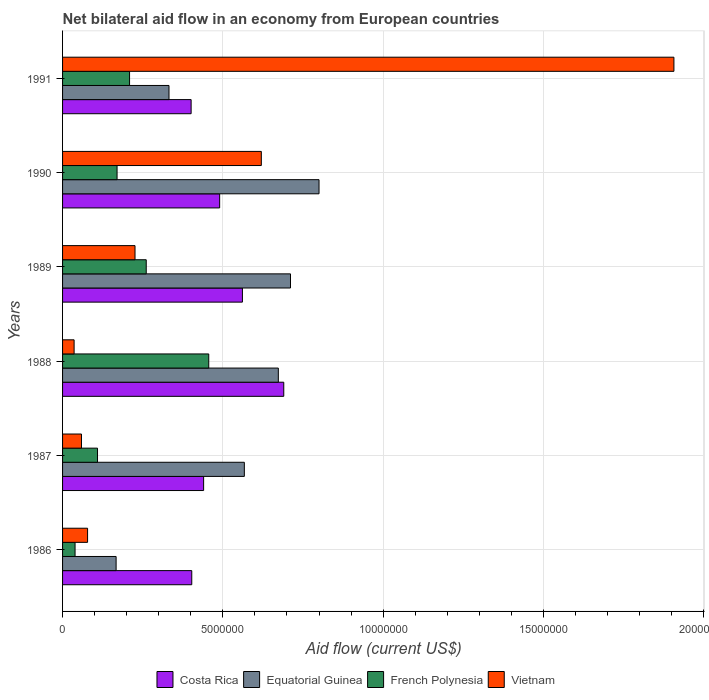How many different coloured bars are there?
Offer a terse response. 4. How many groups of bars are there?
Your answer should be compact. 6. Are the number of bars on each tick of the Y-axis equal?
Give a very brief answer. Yes. How many bars are there on the 3rd tick from the top?
Provide a succinct answer. 4. How many bars are there on the 6th tick from the bottom?
Your response must be concise. 4. What is the net bilateral aid flow in Vietnam in 1986?
Ensure brevity in your answer.  7.80e+05. In which year was the net bilateral aid flow in French Polynesia maximum?
Give a very brief answer. 1988. What is the total net bilateral aid flow in French Polynesia in the graph?
Your answer should be compact. 1.24e+07. What is the difference between the net bilateral aid flow in Costa Rica in 1988 and the net bilateral aid flow in French Polynesia in 1989?
Your response must be concise. 4.29e+06. What is the average net bilateral aid flow in Costa Rica per year?
Your response must be concise. 4.98e+06. In how many years, is the net bilateral aid flow in Costa Rica greater than 7000000 US$?
Provide a succinct answer. 0. What is the ratio of the net bilateral aid flow in French Polynesia in 1989 to that in 1991?
Offer a very short reply. 1.25. Is the net bilateral aid flow in Vietnam in 1987 less than that in 1991?
Your answer should be very brief. Yes. Is the difference between the net bilateral aid flow in Equatorial Guinea in 1989 and 1990 greater than the difference between the net bilateral aid flow in Costa Rica in 1989 and 1990?
Ensure brevity in your answer.  No. What is the difference between the highest and the second highest net bilateral aid flow in Costa Rica?
Offer a terse response. 1.29e+06. What is the difference between the highest and the lowest net bilateral aid flow in Equatorial Guinea?
Provide a short and direct response. 6.33e+06. Is the sum of the net bilateral aid flow in Vietnam in 1990 and 1991 greater than the maximum net bilateral aid flow in Equatorial Guinea across all years?
Make the answer very short. Yes. Is it the case that in every year, the sum of the net bilateral aid flow in Costa Rica and net bilateral aid flow in French Polynesia is greater than the sum of net bilateral aid flow in Vietnam and net bilateral aid flow in Equatorial Guinea?
Your response must be concise. No. What does the 3rd bar from the top in 1989 represents?
Provide a succinct answer. Equatorial Guinea. What does the 2nd bar from the bottom in 1986 represents?
Your answer should be very brief. Equatorial Guinea. Is it the case that in every year, the sum of the net bilateral aid flow in Equatorial Guinea and net bilateral aid flow in Costa Rica is greater than the net bilateral aid flow in Vietnam?
Provide a short and direct response. No. Are all the bars in the graph horizontal?
Offer a terse response. Yes. How many years are there in the graph?
Provide a short and direct response. 6. What is the difference between two consecutive major ticks on the X-axis?
Provide a short and direct response. 5.00e+06. Are the values on the major ticks of X-axis written in scientific E-notation?
Keep it short and to the point. No. Does the graph contain any zero values?
Offer a very short reply. No. How many legend labels are there?
Your response must be concise. 4. What is the title of the graph?
Provide a short and direct response. Net bilateral aid flow in an economy from European countries. What is the label or title of the X-axis?
Provide a short and direct response. Aid flow (current US$). What is the label or title of the Y-axis?
Your answer should be compact. Years. What is the Aid flow (current US$) of Costa Rica in 1986?
Ensure brevity in your answer.  4.03e+06. What is the Aid flow (current US$) in Equatorial Guinea in 1986?
Provide a succinct answer. 1.67e+06. What is the Aid flow (current US$) in Vietnam in 1986?
Offer a very short reply. 7.80e+05. What is the Aid flow (current US$) of Costa Rica in 1987?
Your answer should be very brief. 4.40e+06. What is the Aid flow (current US$) in Equatorial Guinea in 1987?
Make the answer very short. 5.67e+06. What is the Aid flow (current US$) in French Polynesia in 1987?
Your answer should be very brief. 1.09e+06. What is the Aid flow (current US$) of Vietnam in 1987?
Your response must be concise. 5.90e+05. What is the Aid flow (current US$) in Costa Rica in 1988?
Offer a very short reply. 6.90e+06. What is the Aid flow (current US$) in Equatorial Guinea in 1988?
Your answer should be compact. 6.73e+06. What is the Aid flow (current US$) in French Polynesia in 1988?
Offer a terse response. 4.56e+06. What is the Aid flow (current US$) in Costa Rica in 1989?
Your answer should be compact. 5.61e+06. What is the Aid flow (current US$) of Equatorial Guinea in 1989?
Give a very brief answer. 7.11e+06. What is the Aid flow (current US$) of French Polynesia in 1989?
Make the answer very short. 2.61e+06. What is the Aid flow (current US$) in Vietnam in 1989?
Provide a short and direct response. 2.26e+06. What is the Aid flow (current US$) of Costa Rica in 1990?
Provide a short and direct response. 4.90e+06. What is the Aid flow (current US$) of French Polynesia in 1990?
Keep it short and to the point. 1.70e+06. What is the Aid flow (current US$) in Vietnam in 1990?
Provide a succinct answer. 6.20e+06. What is the Aid flow (current US$) in Costa Rica in 1991?
Ensure brevity in your answer.  4.01e+06. What is the Aid flow (current US$) of Equatorial Guinea in 1991?
Your answer should be compact. 3.32e+06. What is the Aid flow (current US$) in French Polynesia in 1991?
Give a very brief answer. 2.09e+06. What is the Aid flow (current US$) in Vietnam in 1991?
Offer a very short reply. 1.91e+07. Across all years, what is the maximum Aid flow (current US$) of Costa Rica?
Give a very brief answer. 6.90e+06. Across all years, what is the maximum Aid flow (current US$) of Equatorial Guinea?
Your response must be concise. 8.00e+06. Across all years, what is the maximum Aid flow (current US$) in French Polynesia?
Make the answer very short. 4.56e+06. Across all years, what is the maximum Aid flow (current US$) of Vietnam?
Make the answer very short. 1.91e+07. Across all years, what is the minimum Aid flow (current US$) in Costa Rica?
Your answer should be compact. 4.01e+06. Across all years, what is the minimum Aid flow (current US$) in Equatorial Guinea?
Offer a very short reply. 1.67e+06. Across all years, what is the minimum Aid flow (current US$) in French Polynesia?
Your answer should be compact. 3.90e+05. What is the total Aid flow (current US$) in Costa Rica in the graph?
Give a very brief answer. 2.98e+07. What is the total Aid flow (current US$) of Equatorial Guinea in the graph?
Keep it short and to the point. 3.25e+07. What is the total Aid flow (current US$) in French Polynesia in the graph?
Provide a short and direct response. 1.24e+07. What is the total Aid flow (current US$) in Vietnam in the graph?
Provide a short and direct response. 2.93e+07. What is the difference between the Aid flow (current US$) in Costa Rica in 1986 and that in 1987?
Your answer should be very brief. -3.70e+05. What is the difference between the Aid flow (current US$) of Equatorial Guinea in 1986 and that in 1987?
Provide a succinct answer. -4.00e+06. What is the difference between the Aid flow (current US$) of French Polynesia in 1986 and that in 1987?
Your response must be concise. -7.00e+05. What is the difference between the Aid flow (current US$) of Costa Rica in 1986 and that in 1988?
Your response must be concise. -2.87e+06. What is the difference between the Aid flow (current US$) in Equatorial Guinea in 1986 and that in 1988?
Keep it short and to the point. -5.06e+06. What is the difference between the Aid flow (current US$) in French Polynesia in 1986 and that in 1988?
Your response must be concise. -4.17e+06. What is the difference between the Aid flow (current US$) in Costa Rica in 1986 and that in 1989?
Offer a very short reply. -1.58e+06. What is the difference between the Aid flow (current US$) in Equatorial Guinea in 1986 and that in 1989?
Your response must be concise. -5.44e+06. What is the difference between the Aid flow (current US$) in French Polynesia in 1986 and that in 1989?
Provide a succinct answer. -2.22e+06. What is the difference between the Aid flow (current US$) in Vietnam in 1986 and that in 1989?
Your response must be concise. -1.48e+06. What is the difference between the Aid flow (current US$) in Costa Rica in 1986 and that in 1990?
Give a very brief answer. -8.70e+05. What is the difference between the Aid flow (current US$) of Equatorial Guinea in 1986 and that in 1990?
Your answer should be compact. -6.33e+06. What is the difference between the Aid flow (current US$) of French Polynesia in 1986 and that in 1990?
Your response must be concise. -1.31e+06. What is the difference between the Aid flow (current US$) of Vietnam in 1986 and that in 1990?
Offer a very short reply. -5.42e+06. What is the difference between the Aid flow (current US$) in Equatorial Guinea in 1986 and that in 1991?
Your answer should be compact. -1.65e+06. What is the difference between the Aid flow (current US$) in French Polynesia in 1986 and that in 1991?
Give a very brief answer. -1.70e+06. What is the difference between the Aid flow (current US$) in Vietnam in 1986 and that in 1991?
Offer a very short reply. -1.83e+07. What is the difference between the Aid flow (current US$) of Costa Rica in 1987 and that in 1988?
Give a very brief answer. -2.50e+06. What is the difference between the Aid flow (current US$) of Equatorial Guinea in 1987 and that in 1988?
Ensure brevity in your answer.  -1.06e+06. What is the difference between the Aid flow (current US$) of French Polynesia in 1987 and that in 1988?
Ensure brevity in your answer.  -3.47e+06. What is the difference between the Aid flow (current US$) of Vietnam in 1987 and that in 1988?
Give a very brief answer. 2.30e+05. What is the difference between the Aid flow (current US$) in Costa Rica in 1987 and that in 1989?
Your answer should be compact. -1.21e+06. What is the difference between the Aid flow (current US$) of Equatorial Guinea in 1987 and that in 1989?
Your answer should be very brief. -1.44e+06. What is the difference between the Aid flow (current US$) of French Polynesia in 1987 and that in 1989?
Your answer should be very brief. -1.52e+06. What is the difference between the Aid flow (current US$) in Vietnam in 1987 and that in 1989?
Give a very brief answer. -1.67e+06. What is the difference between the Aid flow (current US$) in Costa Rica in 1987 and that in 1990?
Offer a terse response. -5.00e+05. What is the difference between the Aid flow (current US$) in Equatorial Guinea in 1987 and that in 1990?
Provide a short and direct response. -2.33e+06. What is the difference between the Aid flow (current US$) in French Polynesia in 1987 and that in 1990?
Ensure brevity in your answer.  -6.10e+05. What is the difference between the Aid flow (current US$) of Vietnam in 1987 and that in 1990?
Your answer should be compact. -5.61e+06. What is the difference between the Aid flow (current US$) of Equatorial Guinea in 1987 and that in 1991?
Provide a short and direct response. 2.35e+06. What is the difference between the Aid flow (current US$) in French Polynesia in 1987 and that in 1991?
Your answer should be compact. -1.00e+06. What is the difference between the Aid flow (current US$) of Vietnam in 1987 and that in 1991?
Your answer should be compact. -1.85e+07. What is the difference between the Aid flow (current US$) of Costa Rica in 1988 and that in 1989?
Your answer should be very brief. 1.29e+06. What is the difference between the Aid flow (current US$) in Equatorial Guinea in 1988 and that in 1989?
Provide a succinct answer. -3.80e+05. What is the difference between the Aid flow (current US$) in French Polynesia in 1988 and that in 1989?
Make the answer very short. 1.95e+06. What is the difference between the Aid flow (current US$) of Vietnam in 1988 and that in 1989?
Your response must be concise. -1.90e+06. What is the difference between the Aid flow (current US$) of Costa Rica in 1988 and that in 1990?
Offer a very short reply. 2.00e+06. What is the difference between the Aid flow (current US$) in Equatorial Guinea in 1988 and that in 1990?
Provide a short and direct response. -1.27e+06. What is the difference between the Aid flow (current US$) of French Polynesia in 1988 and that in 1990?
Your response must be concise. 2.86e+06. What is the difference between the Aid flow (current US$) in Vietnam in 1988 and that in 1990?
Provide a short and direct response. -5.84e+06. What is the difference between the Aid flow (current US$) in Costa Rica in 1988 and that in 1991?
Offer a very short reply. 2.89e+06. What is the difference between the Aid flow (current US$) of Equatorial Guinea in 1988 and that in 1991?
Keep it short and to the point. 3.41e+06. What is the difference between the Aid flow (current US$) in French Polynesia in 1988 and that in 1991?
Offer a terse response. 2.47e+06. What is the difference between the Aid flow (current US$) of Vietnam in 1988 and that in 1991?
Keep it short and to the point. -1.87e+07. What is the difference between the Aid flow (current US$) of Costa Rica in 1989 and that in 1990?
Give a very brief answer. 7.10e+05. What is the difference between the Aid flow (current US$) in Equatorial Guinea in 1989 and that in 1990?
Keep it short and to the point. -8.90e+05. What is the difference between the Aid flow (current US$) in French Polynesia in 1989 and that in 1990?
Make the answer very short. 9.10e+05. What is the difference between the Aid flow (current US$) of Vietnam in 1989 and that in 1990?
Offer a terse response. -3.94e+06. What is the difference between the Aid flow (current US$) of Costa Rica in 1989 and that in 1991?
Offer a very short reply. 1.60e+06. What is the difference between the Aid flow (current US$) in Equatorial Guinea in 1989 and that in 1991?
Keep it short and to the point. 3.79e+06. What is the difference between the Aid flow (current US$) of French Polynesia in 1989 and that in 1991?
Your answer should be compact. 5.20e+05. What is the difference between the Aid flow (current US$) in Vietnam in 1989 and that in 1991?
Provide a succinct answer. -1.68e+07. What is the difference between the Aid flow (current US$) in Costa Rica in 1990 and that in 1991?
Your answer should be compact. 8.90e+05. What is the difference between the Aid flow (current US$) of Equatorial Guinea in 1990 and that in 1991?
Your answer should be very brief. 4.68e+06. What is the difference between the Aid flow (current US$) in French Polynesia in 1990 and that in 1991?
Your answer should be very brief. -3.90e+05. What is the difference between the Aid flow (current US$) of Vietnam in 1990 and that in 1991?
Offer a terse response. -1.29e+07. What is the difference between the Aid flow (current US$) of Costa Rica in 1986 and the Aid flow (current US$) of Equatorial Guinea in 1987?
Keep it short and to the point. -1.64e+06. What is the difference between the Aid flow (current US$) of Costa Rica in 1986 and the Aid flow (current US$) of French Polynesia in 1987?
Ensure brevity in your answer.  2.94e+06. What is the difference between the Aid flow (current US$) of Costa Rica in 1986 and the Aid flow (current US$) of Vietnam in 1987?
Offer a terse response. 3.44e+06. What is the difference between the Aid flow (current US$) in Equatorial Guinea in 1986 and the Aid flow (current US$) in French Polynesia in 1987?
Provide a succinct answer. 5.80e+05. What is the difference between the Aid flow (current US$) in Equatorial Guinea in 1986 and the Aid flow (current US$) in Vietnam in 1987?
Your answer should be compact. 1.08e+06. What is the difference between the Aid flow (current US$) of Costa Rica in 1986 and the Aid flow (current US$) of Equatorial Guinea in 1988?
Offer a very short reply. -2.70e+06. What is the difference between the Aid flow (current US$) in Costa Rica in 1986 and the Aid flow (current US$) in French Polynesia in 1988?
Offer a very short reply. -5.30e+05. What is the difference between the Aid flow (current US$) of Costa Rica in 1986 and the Aid flow (current US$) of Vietnam in 1988?
Your answer should be compact. 3.67e+06. What is the difference between the Aid flow (current US$) in Equatorial Guinea in 1986 and the Aid flow (current US$) in French Polynesia in 1988?
Provide a succinct answer. -2.89e+06. What is the difference between the Aid flow (current US$) in Equatorial Guinea in 1986 and the Aid flow (current US$) in Vietnam in 1988?
Your response must be concise. 1.31e+06. What is the difference between the Aid flow (current US$) of Costa Rica in 1986 and the Aid flow (current US$) of Equatorial Guinea in 1989?
Give a very brief answer. -3.08e+06. What is the difference between the Aid flow (current US$) in Costa Rica in 1986 and the Aid flow (current US$) in French Polynesia in 1989?
Your answer should be very brief. 1.42e+06. What is the difference between the Aid flow (current US$) in Costa Rica in 1986 and the Aid flow (current US$) in Vietnam in 1989?
Ensure brevity in your answer.  1.77e+06. What is the difference between the Aid flow (current US$) in Equatorial Guinea in 1986 and the Aid flow (current US$) in French Polynesia in 1989?
Your answer should be compact. -9.40e+05. What is the difference between the Aid flow (current US$) in Equatorial Guinea in 1986 and the Aid flow (current US$) in Vietnam in 1989?
Make the answer very short. -5.90e+05. What is the difference between the Aid flow (current US$) of French Polynesia in 1986 and the Aid flow (current US$) of Vietnam in 1989?
Ensure brevity in your answer.  -1.87e+06. What is the difference between the Aid flow (current US$) of Costa Rica in 1986 and the Aid flow (current US$) of Equatorial Guinea in 1990?
Provide a succinct answer. -3.97e+06. What is the difference between the Aid flow (current US$) of Costa Rica in 1986 and the Aid flow (current US$) of French Polynesia in 1990?
Offer a very short reply. 2.33e+06. What is the difference between the Aid flow (current US$) of Costa Rica in 1986 and the Aid flow (current US$) of Vietnam in 1990?
Offer a terse response. -2.17e+06. What is the difference between the Aid flow (current US$) of Equatorial Guinea in 1986 and the Aid flow (current US$) of French Polynesia in 1990?
Ensure brevity in your answer.  -3.00e+04. What is the difference between the Aid flow (current US$) of Equatorial Guinea in 1986 and the Aid flow (current US$) of Vietnam in 1990?
Provide a short and direct response. -4.53e+06. What is the difference between the Aid flow (current US$) of French Polynesia in 1986 and the Aid flow (current US$) of Vietnam in 1990?
Give a very brief answer. -5.81e+06. What is the difference between the Aid flow (current US$) in Costa Rica in 1986 and the Aid flow (current US$) in Equatorial Guinea in 1991?
Offer a terse response. 7.10e+05. What is the difference between the Aid flow (current US$) in Costa Rica in 1986 and the Aid flow (current US$) in French Polynesia in 1991?
Your answer should be very brief. 1.94e+06. What is the difference between the Aid flow (current US$) in Costa Rica in 1986 and the Aid flow (current US$) in Vietnam in 1991?
Give a very brief answer. -1.50e+07. What is the difference between the Aid flow (current US$) of Equatorial Guinea in 1986 and the Aid flow (current US$) of French Polynesia in 1991?
Your response must be concise. -4.20e+05. What is the difference between the Aid flow (current US$) of Equatorial Guinea in 1986 and the Aid flow (current US$) of Vietnam in 1991?
Ensure brevity in your answer.  -1.74e+07. What is the difference between the Aid flow (current US$) in French Polynesia in 1986 and the Aid flow (current US$) in Vietnam in 1991?
Offer a terse response. -1.87e+07. What is the difference between the Aid flow (current US$) of Costa Rica in 1987 and the Aid flow (current US$) of Equatorial Guinea in 1988?
Your answer should be very brief. -2.33e+06. What is the difference between the Aid flow (current US$) of Costa Rica in 1987 and the Aid flow (current US$) of Vietnam in 1988?
Your answer should be very brief. 4.04e+06. What is the difference between the Aid flow (current US$) in Equatorial Guinea in 1987 and the Aid flow (current US$) in French Polynesia in 1988?
Ensure brevity in your answer.  1.11e+06. What is the difference between the Aid flow (current US$) of Equatorial Guinea in 1987 and the Aid flow (current US$) of Vietnam in 1988?
Ensure brevity in your answer.  5.31e+06. What is the difference between the Aid flow (current US$) in French Polynesia in 1987 and the Aid flow (current US$) in Vietnam in 1988?
Ensure brevity in your answer.  7.30e+05. What is the difference between the Aid flow (current US$) of Costa Rica in 1987 and the Aid flow (current US$) of Equatorial Guinea in 1989?
Provide a short and direct response. -2.71e+06. What is the difference between the Aid flow (current US$) of Costa Rica in 1987 and the Aid flow (current US$) of French Polynesia in 1989?
Ensure brevity in your answer.  1.79e+06. What is the difference between the Aid flow (current US$) of Costa Rica in 1987 and the Aid flow (current US$) of Vietnam in 1989?
Offer a very short reply. 2.14e+06. What is the difference between the Aid flow (current US$) in Equatorial Guinea in 1987 and the Aid flow (current US$) in French Polynesia in 1989?
Ensure brevity in your answer.  3.06e+06. What is the difference between the Aid flow (current US$) in Equatorial Guinea in 1987 and the Aid flow (current US$) in Vietnam in 1989?
Your answer should be very brief. 3.41e+06. What is the difference between the Aid flow (current US$) of French Polynesia in 1987 and the Aid flow (current US$) of Vietnam in 1989?
Offer a very short reply. -1.17e+06. What is the difference between the Aid flow (current US$) in Costa Rica in 1987 and the Aid flow (current US$) in Equatorial Guinea in 1990?
Keep it short and to the point. -3.60e+06. What is the difference between the Aid flow (current US$) in Costa Rica in 1987 and the Aid flow (current US$) in French Polynesia in 1990?
Your answer should be very brief. 2.70e+06. What is the difference between the Aid flow (current US$) in Costa Rica in 1987 and the Aid flow (current US$) in Vietnam in 1990?
Make the answer very short. -1.80e+06. What is the difference between the Aid flow (current US$) in Equatorial Guinea in 1987 and the Aid flow (current US$) in French Polynesia in 1990?
Your response must be concise. 3.97e+06. What is the difference between the Aid flow (current US$) in Equatorial Guinea in 1987 and the Aid flow (current US$) in Vietnam in 1990?
Ensure brevity in your answer.  -5.30e+05. What is the difference between the Aid flow (current US$) in French Polynesia in 1987 and the Aid flow (current US$) in Vietnam in 1990?
Offer a very short reply. -5.11e+06. What is the difference between the Aid flow (current US$) in Costa Rica in 1987 and the Aid flow (current US$) in Equatorial Guinea in 1991?
Keep it short and to the point. 1.08e+06. What is the difference between the Aid flow (current US$) in Costa Rica in 1987 and the Aid flow (current US$) in French Polynesia in 1991?
Your response must be concise. 2.31e+06. What is the difference between the Aid flow (current US$) of Costa Rica in 1987 and the Aid flow (current US$) of Vietnam in 1991?
Offer a terse response. -1.47e+07. What is the difference between the Aid flow (current US$) of Equatorial Guinea in 1987 and the Aid flow (current US$) of French Polynesia in 1991?
Make the answer very short. 3.58e+06. What is the difference between the Aid flow (current US$) of Equatorial Guinea in 1987 and the Aid flow (current US$) of Vietnam in 1991?
Offer a terse response. -1.34e+07. What is the difference between the Aid flow (current US$) of French Polynesia in 1987 and the Aid flow (current US$) of Vietnam in 1991?
Offer a terse response. -1.80e+07. What is the difference between the Aid flow (current US$) in Costa Rica in 1988 and the Aid flow (current US$) in French Polynesia in 1989?
Provide a short and direct response. 4.29e+06. What is the difference between the Aid flow (current US$) of Costa Rica in 1988 and the Aid flow (current US$) of Vietnam in 1989?
Offer a very short reply. 4.64e+06. What is the difference between the Aid flow (current US$) in Equatorial Guinea in 1988 and the Aid flow (current US$) in French Polynesia in 1989?
Make the answer very short. 4.12e+06. What is the difference between the Aid flow (current US$) of Equatorial Guinea in 1988 and the Aid flow (current US$) of Vietnam in 1989?
Give a very brief answer. 4.47e+06. What is the difference between the Aid flow (current US$) of French Polynesia in 1988 and the Aid flow (current US$) of Vietnam in 1989?
Your answer should be compact. 2.30e+06. What is the difference between the Aid flow (current US$) of Costa Rica in 1988 and the Aid flow (current US$) of Equatorial Guinea in 1990?
Offer a very short reply. -1.10e+06. What is the difference between the Aid flow (current US$) in Costa Rica in 1988 and the Aid flow (current US$) in French Polynesia in 1990?
Keep it short and to the point. 5.20e+06. What is the difference between the Aid flow (current US$) of Costa Rica in 1988 and the Aid flow (current US$) of Vietnam in 1990?
Give a very brief answer. 7.00e+05. What is the difference between the Aid flow (current US$) of Equatorial Guinea in 1988 and the Aid flow (current US$) of French Polynesia in 1990?
Provide a succinct answer. 5.03e+06. What is the difference between the Aid flow (current US$) of Equatorial Guinea in 1988 and the Aid flow (current US$) of Vietnam in 1990?
Keep it short and to the point. 5.30e+05. What is the difference between the Aid flow (current US$) in French Polynesia in 1988 and the Aid flow (current US$) in Vietnam in 1990?
Ensure brevity in your answer.  -1.64e+06. What is the difference between the Aid flow (current US$) of Costa Rica in 1988 and the Aid flow (current US$) of Equatorial Guinea in 1991?
Provide a short and direct response. 3.58e+06. What is the difference between the Aid flow (current US$) in Costa Rica in 1988 and the Aid flow (current US$) in French Polynesia in 1991?
Make the answer very short. 4.81e+06. What is the difference between the Aid flow (current US$) in Costa Rica in 1988 and the Aid flow (current US$) in Vietnam in 1991?
Make the answer very short. -1.22e+07. What is the difference between the Aid flow (current US$) in Equatorial Guinea in 1988 and the Aid flow (current US$) in French Polynesia in 1991?
Ensure brevity in your answer.  4.64e+06. What is the difference between the Aid flow (current US$) in Equatorial Guinea in 1988 and the Aid flow (current US$) in Vietnam in 1991?
Your answer should be very brief. -1.23e+07. What is the difference between the Aid flow (current US$) in French Polynesia in 1988 and the Aid flow (current US$) in Vietnam in 1991?
Provide a short and direct response. -1.45e+07. What is the difference between the Aid flow (current US$) in Costa Rica in 1989 and the Aid flow (current US$) in Equatorial Guinea in 1990?
Offer a terse response. -2.39e+06. What is the difference between the Aid flow (current US$) of Costa Rica in 1989 and the Aid flow (current US$) of French Polynesia in 1990?
Provide a succinct answer. 3.91e+06. What is the difference between the Aid flow (current US$) of Costa Rica in 1989 and the Aid flow (current US$) of Vietnam in 1990?
Provide a short and direct response. -5.90e+05. What is the difference between the Aid flow (current US$) of Equatorial Guinea in 1989 and the Aid flow (current US$) of French Polynesia in 1990?
Make the answer very short. 5.41e+06. What is the difference between the Aid flow (current US$) in Equatorial Guinea in 1989 and the Aid flow (current US$) in Vietnam in 1990?
Keep it short and to the point. 9.10e+05. What is the difference between the Aid flow (current US$) in French Polynesia in 1989 and the Aid flow (current US$) in Vietnam in 1990?
Keep it short and to the point. -3.59e+06. What is the difference between the Aid flow (current US$) in Costa Rica in 1989 and the Aid flow (current US$) in Equatorial Guinea in 1991?
Ensure brevity in your answer.  2.29e+06. What is the difference between the Aid flow (current US$) in Costa Rica in 1989 and the Aid flow (current US$) in French Polynesia in 1991?
Provide a short and direct response. 3.52e+06. What is the difference between the Aid flow (current US$) in Costa Rica in 1989 and the Aid flow (current US$) in Vietnam in 1991?
Keep it short and to the point. -1.35e+07. What is the difference between the Aid flow (current US$) of Equatorial Guinea in 1989 and the Aid flow (current US$) of French Polynesia in 1991?
Provide a succinct answer. 5.02e+06. What is the difference between the Aid flow (current US$) in Equatorial Guinea in 1989 and the Aid flow (current US$) in Vietnam in 1991?
Keep it short and to the point. -1.20e+07. What is the difference between the Aid flow (current US$) in French Polynesia in 1989 and the Aid flow (current US$) in Vietnam in 1991?
Provide a succinct answer. -1.65e+07. What is the difference between the Aid flow (current US$) of Costa Rica in 1990 and the Aid flow (current US$) of Equatorial Guinea in 1991?
Give a very brief answer. 1.58e+06. What is the difference between the Aid flow (current US$) of Costa Rica in 1990 and the Aid flow (current US$) of French Polynesia in 1991?
Keep it short and to the point. 2.81e+06. What is the difference between the Aid flow (current US$) in Costa Rica in 1990 and the Aid flow (current US$) in Vietnam in 1991?
Ensure brevity in your answer.  -1.42e+07. What is the difference between the Aid flow (current US$) of Equatorial Guinea in 1990 and the Aid flow (current US$) of French Polynesia in 1991?
Your answer should be compact. 5.91e+06. What is the difference between the Aid flow (current US$) of Equatorial Guinea in 1990 and the Aid flow (current US$) of Vietnam in 1991?
Ensure brevity in your answer.  -1.11e+07. What is the difference between the Aid flow (current US$) of French Polynesia in 1990 and the Aid flow (current US$) of Vietnam in 1991?
Ensure brevity in your answer.  -1.74e+07. What is the average Aid flow (current US$) in Costa Rica per year?
Offer a terse response. 4.98e+06. What is the average Aid flow (current US$) of Equatorial Guinea per year?
Offer a terse response. 5.42e+06. What is the average Aid flow (current US$) of French Polynesia per year?
Offer a terse response. 2.07e+06. What is the average Aid flow (current US$) in Vietnam per year?
Provide a short and direct response. 4.88e+06. In the year 1986, what is the difference between the Aid flow (current US$) in Costa Rica and Aid flow (current US$) in Equatorial Guinea?
Ensure brevity in your answer.  2.36e+06. In the year 1986, what is the difference between the Aid flow (current US$) in Costa Rica and Aid flow (current US$) in French Polynesia?
Give a very brief answer. 3.64e+06. In the year 1986, what is the difference between the Aid flow (current US$) of Costa Rica and Aid flow (current US$) of Vietnam?
Your answer should be very brief. 3.25e+06. In the year 1986, what is the difference between the Aid flow (current US$) in Equatorial Guinea and Aid flow (current US$) in French Polynesia?
Ensure brevity in your answer.  1.28e+06. In the year 1986, what is the difference between the Aid flow (current US$) in Equatorial Guinea and Aid flow (current US$) in Vietnam?
Your answer should be very brief. 8.90e+05. In the year 1986, what is the difference between the Aid flow (current US$) of French Polynesia and Aid flow (current US$) of Vietnam?
Your response must be concise. -3.90e+05. In the year 1987, what is the difference between the Aid flow (current US$) in Costa Rica and Aid flow (current US$) in Equatorial Guinea?
Ensure brevity in your answer.  -1.27e+06. In the year 1987, what is the difference between the Aid flow (current US$) of Costa Rica and Aid flow (current US$) of French Polynesia?
Make the answer very short. 3.31e+06. In the year 1987, what is the difference between the Aid flow (current US$) of Costa Rica and Aid flow (current US$) of Vietnam?
Your answer should be compact. 3.81e+06. In the year 1987, what is the difference between the Aid flow (current US$) of Equatorial Guinea and Aid flow (current US$) of French Polynesia?
Offer a terse response. 4.58e+06. In the year 1987, what is the difference between the Aid flow (current US$) of Equatorial Guinea and Aid flow (current US$) of Vietnam?
Your answer should be compact. 5.08e+06. In the year 1988, what is the difference between the Aid flow (current US$) in Costa Rica and Aid flow (current US$) in Equatorial Guinea?
Give a very brief answer. 1.70e+05. In the year 1988, what is the difference between the Aid flow (current US$) in Costa Rica and Aid flow (current US$) in French Polynesia?
Offer a terse response. 2.34e+06. In the year 1988, what is the difference between the Aid flow (current US$) of Costa Rica and Aid flow (current US$) of Vietnam?
Your answer should be compact. 6.54e+06. In the year 1988, what is the difference between the Aid flow (current US$) of Equatorial Guinea and Aid flow (current US$) of French Polynesia?
Offer a terse response. 2.17e+06. In the year 1988, what is the difference between the Aid flow (current US$) of Equatorial Guinea and Aid flow (current US$) of Vietnam?
Provide a short and direct response. 6.37e+06. In the year 1988, what is the difference between the Aid flow (current US$) of French Polynesia and Aid flow (current US$) of Vietnam?
Your response must be concise. 4.20e+06. In the year 1989, what is the difference between the Aid flow (current US$) of Costa Rica and Aid flow (current US$) of Equatorial Guinea?
Ensure brevity in your answer.  -1.50e+06. In the year 1989, what is the difference between the Aid flow (current US$) in Costa Rica and Aid flow (current US$) in French Polynesia?
Offer a very short reply. 3.00e+06. In the year 1989, what is the difference between the Aid flow (current US$) in Costa Rica and Aid flow (current US$) in Vietnam?
Offer a very short reply. 3.35e+06. In the year 1989, what is the difference between the Aid flow (current US$) of Equatorial Guinea and Aid flow (current US$) of French Polynesia?
Keep it short and to the point. 4.50e+06. In the year 1989, what is the difference between the Aid flow (current US$) of Equatorial Guinea and Aid flow (current US$) of Vietnam?
Provide a succinct answer. 4.85e+06. In the year 1990, what is the difference between the Aid flow (current US$) of Costa Rica and Aid flow (current US$) of Equatorial Guinea?
Provide a short and direct response. -3.10e+06. In the year 1990, what is the difference between the Aid flow (current US$) in Costa Rica and Aid flow (current US$) in French Polynesia?
Keep it short and to the point. 3.20e+06. In the year 1990, what is the difference between the Aid flow (current US$) of Costa Rica and Aid flow (current US$) of Vietnam?
Your response must be concise. -1.30e+06. In the year 1990, what is the difference between the Aid flow (current US$) in Equatorial Guinea and Aid flow (current US$) in French Polynesia?
Your answer should be compact. 6.30e+06. In the year 1990, what is the difference between the Aid flow (current US$) of Equatorial Guinea and Aid flow (current US$) of Vietnam?
Give a very brief answer. 1.80e+06. In the year 1990, what is the difference between the Aid flow (current US$) of French Polynesia and Aid flow (current US$) of Vietnam?
Offer a terse response. -4.50e+06. In the year 1991, what is the difference between the Aid flow (current US$) in Costa Rica and Aid flow (current US$) in Equatorial Guinea?
Provide a succinct answer. 6.90e+05. In the year 1991, what is the difference between the Aid flow (current US$) in Costa Rica and Aid flow (current US$) in French Polynesia?
Provide a short and direct response. 1.92e+06. In the year 1991, what is the difference between the Aid flow (current US$) of Costa Rica and Aid flow (current US$) of Vietnam?
Your answer should be compact. -1.51e+07. In the year 1991, what is the difference between the Aid flow (current US$) in Equatorial Guinea and Aid flow (current US$) in French Polynesia?
Your answer should be very brief. 1.23e+06. In the year 1991, what is the difference between the Aid flow (current US$) of Equatorial Guinea and Aid flow (current US$) of Vietnam?
Provide a short and direct response. -1.58e+07. In the year 1991, what is the difference between the Aid flow (current US$) of French Polynesia and Aid flow (current US$) of Vietnam?
Keep it short and to the point. -1.70e+07. What is the ratio of the Aid flow (current US$) of Costa Rica in 1986 to that in 1987?
Offer a very short reply. 0.92. What is the ratio of the Aid flow (current US$) in Equatorial Guinea in 1986 to that in 1987?
Your response must be concise. 0.29. What is the ratio of the Aid flow (current US$) of French Polynesia in 1986 to that in 1987?
Provide a short and direct response. 0.36. What is the ratio of the Aid flow (current US$) of Vietnam in 1986 to that in 1987?
Give a very brief answer. 1.32. What is the ratio of the Aid flow (current US$) in Costa Rica in 1986 to that in 1988?
Provide a short and direct response. 0.58. What is the ratio of the Aid flow (current US$) in Equatorial Guinea in 1986 to that in 1988?
Keep it short and to the point. 0.25. What is the ratio of the Aid flow (current US$) of French Polynesia in 1986 to that in 1988?
Give a very brief answer. 0.09. What is the ratio of the Aid flow (current US$) in Vietnam in 1986 to that in 1988?
Give a very brief answer. 2.17. What is the ratio of the Aid flow (current US$) of Costa Rica in 1986 to that in 1989?
Your response must be concise. 0.72. What is the ratio of the Aid flow (current US$) of Equatorial Guinea in 1986 to that in 1989?
Give a very brief answer. 0.23. What is the ratio of the Aid flow (current US$) of French Polynesia in 1986 to that in 1989?
Ensure brevity in your answer.  0.15. What is the ratio of the Aid flow (current US$) in Vietnam in 1986 to that in 1989?
Provide a short and direct response. 0.35. What is the ratio of the Aid flow (current US$) in Costa Rica in 1986 to that in 1990?
Your answer should be very brief. 0.82. What is the ratio of the Aid flow (current US$) of Equatorial Guinea in 1986 to that in 1990?
Keep it short and to the point. 0.21. What is the ratio of the Aid flow (current US$) of French Polynesia in 1986 to that in 1990?
Offer a terse response. 0.23. What is the ratio of the Aid flow (current US$) of Vietnam in 1986 to that in 1990?
Keep it short and to the point. 0.13. What is the ratio of the Aid flow (current US$) in Costa Rica in 1986 to that in 1991?
Your response must be concise. 1. What is the ratio of the Aid flow (current US$) in Equatorial Guinea in 1986 to that in 1991?
Offer a terse response. 0.5. What is the ratio of the Aid flow (current US$) in French Polynesia in 1986 to that in 1991?
Keep it short and to the point. 0.19. What is the ratio of the Aid flow (current US$) of Vietnam in 1986 to that in 1991?
Keep it short and to the point. 0.04. What is the ratio of the Aid flow (current US$) of Costa Rica in 1987 to that in 1988?
Your response must be concise. 0.64. What is the ratio of the Aid flow (current US$) in Equatorial Guinea in 1987 to that in 1988?
Offer a very short reply. 0.84. What is the ratio of the Aid flow (current US$) in French Polynesia in 1987 to that in 1988?
Ensure brevity in your answer.  0.24. What is the ratio of the Aid flow (current US$) in Vietnam in 1987 to that in 1988?
Offer a terse response. 1.64. What is the ratio of the Aid flow (current US$) of Costa Rica in 1987 to that in 1989?
Ensure brevity in your answer.  0.78. What is the ratio of the Aid flow (current US$) of Equatorial Guinea in 1987 to that in 1989?
Offer a terse response. 0.8. What is the ratio of the Aid flow (current US$) of French Polynesia in 1987 to that in 1989?
Your answer should be compact. 0.42. What is the ratio of the Aid flow (current US$) of Vietnam in 1987 to that in 1989?
Offer a terse response. 0.26. What is the ratio of the Aid flow (current US$) in Costa Rica in 1987 to that in 1990?
Ensure brevity in your answer.  0.9. What is the ratio of the Aid flow (current US$) of Equatorial Guinea in 1987 to that in 1990?
Provide a short and direct response. 0.71. What is the ratio of the Aid flow (current US$) of French Polynesia in 1987 to that in 1990?
Ensure brevity in your answer.  0.64. What is the ratio of the Aid flow (current US$) in Vietnam in 1987 to that in 1990?
Your answer should be compact. 0.1. What is the ratio of the Aid flow (current US$) in Costa Rica in 1987 to that in 1991?
Offer a terse response. 1.1. What is the ratio of the Aid flow (current US$) in Equatorial Guinea in 1987 to that in 1991?
Offer a terse response. 1.71. What is the ratio of the Aid flow (current US$) of French Polynesia in 1987 to that in 1991?
Provide a succinct answer. 0.52. What is the ratio of the Aid flow (current US$) of Vietnam in 1987 to that in 1991?
Ensure brevity in your answer.  0.03. What is the ratio of the Aid flow (current US$) of Costa Rica in 1988 to that in 1989?
Make the answer very short. 1.23. What is the ratio of the Aid flow (current US$) of Equatorial Guinea in 1988 to that in 1989?
Provide a short and direct response. 0.95. What is the ratio of the Aid flow (current US$) in French Polynesia in 1988 to that in 1989?
Your answer should be very brief. 1.75. What is the ratio of the Aid flow (current US$) in Vietnam in 1988 to that in 1989?
Your answer should be compact. 0.16. What is the ratio of the Aid flow (current US$) of Costa Rica in 1988 to that in 1990?
Keep it short and to the point. 1.41. What is the ratio of the Aid flow (current US$) of Equatorial Guinea in 1988 to that in 1990?
Ensure brevity in your answer.  0.84. What is the ratio of the Aid flow (current US$) in French Polynesia in 1988 to that in 1990?
Provide a succinct answer. 2.68. What is the ratio of the Aid flow (current US$) of Vietnam in 1988 to that in 1990?
Offer a very short reply. 0.06. What is the ratio of the Aid flow (current US$) of Costa Rica in 1988 to that in 1991?
Offer a terse response. 1.72. What is the ratio of the Aid flow (current US$) of Equatorial Guinea in 1988 to that in 1991?
Provide a succinct answer. 2.03. What is the ratio of the Aid flow (current US$) in French Polynesia in 1988 to that in 1991?
Offer a very short reply. 2.18. What is the ratio of the Aid flow (current US$) in Vietnam in 1988 to that in 1991?
Give a very brief answer. 0.02. What is the ratio of the Aid flow (current US$) of Costa Rica in 1989 to that in 1990?
Offer a very short reply. 1.14. What is the ratio of the Aid flow (current US$) in Equatorial Guinea in 1989 to that in 1990?
Your response must be concise. 0.89. What is the ratio of the Aid flow (current US$) in French Polynesia in 1989 to that in 1990?
Keep it short and to the point. 1.54. What is the ratio of the Aid flow (current US$) in Vietnam in 1989 to that in 1990?
Make the answer very short. 0.36. What is the ratio of the Aid flow (current US$) in Costa Rica in 1989 to that in 1991?
Make the answer very short. 1.4. What is the ratio of the Aid flow (current US$) in Equatorial Guinea in 1989 to that in 1991?
Ensure brevity in your answer.  2.14. What is the ratio of the Aid flow (current US$) of French Polynesia in 1989 to that in 1991?
Provide a short and direct response. 1.25. What is the ratio of the Aid flow (current US$) in Vietnam in 1989 to that in 1991?
Give a very brief answer. 0.12. What is the ratio of the Aid flow (current US$) in Costa Rica in 1990 to that in 1991?
Make the answer very short. 1.22. What is the ratio of the Aid flow (current US$) in Equatorial Guinea in 1990 to that in 1991?
Offer a very short reply. 2.41. What is the ratio of the Aid flow (current US$) in French Polynesia in 1990 to that in 1991?
Ensure brevity in your answer.  0.81. What is the ratio of the Aid flow (current US$) in Vietnam in 1990 to that in 1991?
Provide a succinct answer. 0.33. What is the difference between the highest and the second highest Aid flow (current US$) of Costa Rica?
Provide a succinct answer. 1.29e+06. What is the difference between the highest and the second highest Aid flow (current US$) of Equatorial Guinea?
Give a very brief answer. 8.90e+05. What is the difference between the highest and the second highest Aid flow (current US$) of French Polynesia?
Provide a short and direct response. 1.95e+06. What is the difference between the highest and the second highest Aid flow (current US$) of Vietnam?
Keep it short and to the point. 1.29e+07. What is the difference between the highest and the lowest Aid flow (current US$) in Costa Rica?
Your answer should be very brief. 2.89e+06. What is the difference between the highest and the lowest Aid flow (current US$) of Equatorial Guinea?
Provide a succinct answer. 6.33e+06. What is the difference between the highest and the lowest Aid flow (current US$) of French Polynesia?
Your response must be concise. 4.17e+06. What is the difference between the highest and the lowest Aid flow (current US$) in Vietnam?
Keep it short and to the point. 1.87e+07. 